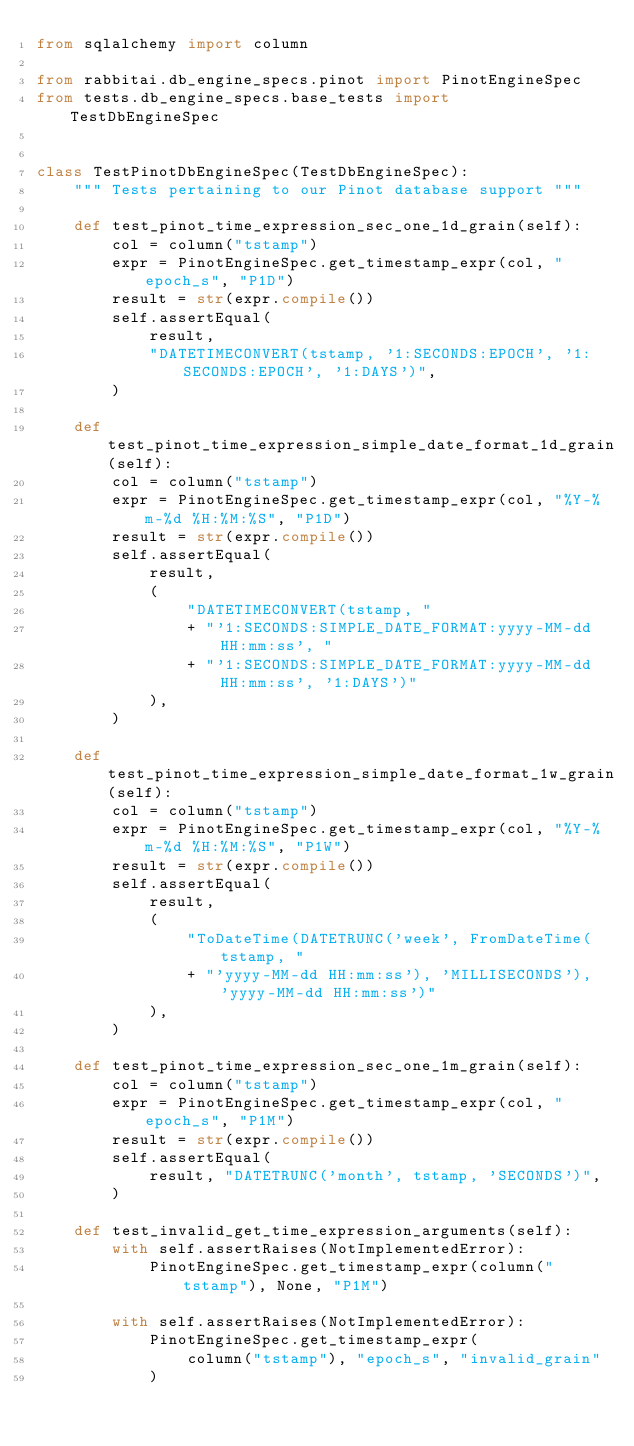Convert code to text. <code><loc_0><loc_0><loc_500><loc_500><_Python_>from sqlalchemy import column

from rabbitai.db_engine_specs.pinot import PinotEngineSpec
from tests.db_engine_specs.base_tests import TestDbEngineSpec


class TestPinotDbEngineSpec(TestDbEngineSpec):
    """ Tests pertaining to our Pinot database support """

    def test_pinot_time_expression_sec_one_1d_grain(self):
        col = column("tstamp")
        expr = PinotEngineSpec.get_timestamp_expr(col, "epoch_s", "P1D")
        result = str(expr.compile())
        self.assertEqual(
            result,
            "DATETIMECONVERT(tstamp, '1:SECONDS:EPOCH', '1:SECONDS:EPOCH', '1:DAYS')",
        )

    def test_pinot_time_expression_simple_date_format_1d_grain(self):
        col = column("tstamp")
        expr = PinotEngineSpec.get_timestamp_expr(col, "%Y-%m-%d %H:%M:%S", "P1D")
        result = str(expr.compile())
        self.assertEqual(
            result,
            (
                "DATETIMECONVERT(tstamp, "
                + "'1:SECONDS:SIMPLE_DATE_FORMAT:yyyy-MM-dd HH:mm:ss', "
                + "'1:SECONDS:SIMPLE_DATE_FORMAT:yyyy-MM-dd HH:mm:ss', '1:DAYS')"
            ),
        )

    def test_pinot_time_expression_simple_date_format_1w_grain(self):
        col = column("tstamp")
        expr = PinotEngineSpec.get_timestamp_expr(col, "%Y-%m-%d %H:%M:%S", "P1W")
        result = str(expr.compile())
        self.assertEqual(
            result,
            (
                "ToDateTime(DATETRUNC('week', FromDateTime(tstamp, "
                + "'yyyy-MM-dd HH:mm:ss'), 'MILLISECONDS'), 'yyyy-MM-dd HH:mm:ss')"
            ),
        )

    def test_pinot_time_expression_sec_one_1m_grain(self):
        col = column("tstamp")
        expr = PinotEngineSpec.get_timestamp_expr(col, "epoch_s", "P1M")
        result = str(expr.compile())
        self.assertEqual(
            result, "DATETRUNC('month', tstamp, 'SECONDS')",
        )

    def test_invalid_get_time_expression_arguments(self):
        with self.assertRaises(NotImplementedError):
            PinotEngineSpec.get_timestamp_expr(column("tstamp"), None, "P1M")

        with self.assertRaises(NotImplementedError):
            PinotEngineSpec.get_timestamp_expr(
                column("tstamp"), "epoch_s", "invalid_grain"
            )
</code> 